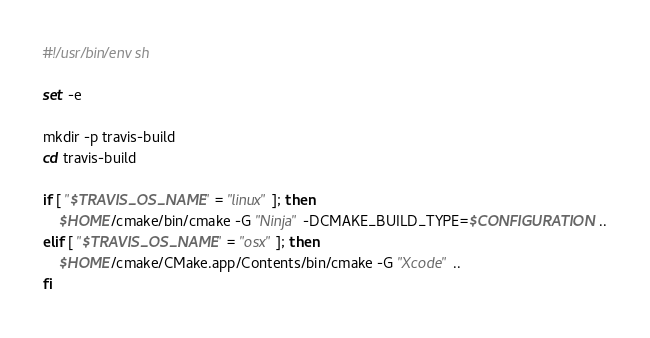Convert code to text. <code><loc_0><loc_0><loc_500><loc_500><_Bash_>#!/usr/bin/env sh

set -e

mkdir -p travis-build
cd travis-build

if [ "$TRAVIS_OS_NAME" = "linux" ]; then
    $HOME/cmake/bin/cmake -G "Ninja" -DCMAKE_BUILD_TYPE=$CONFIGURATION ..
elif [ "$TRAVIS_OS_NAME" = "osx" ]; then
    $HOME/cmake/CMake.app/Contents/bin/cmake -G "Xcode" ..
fi
</code> 